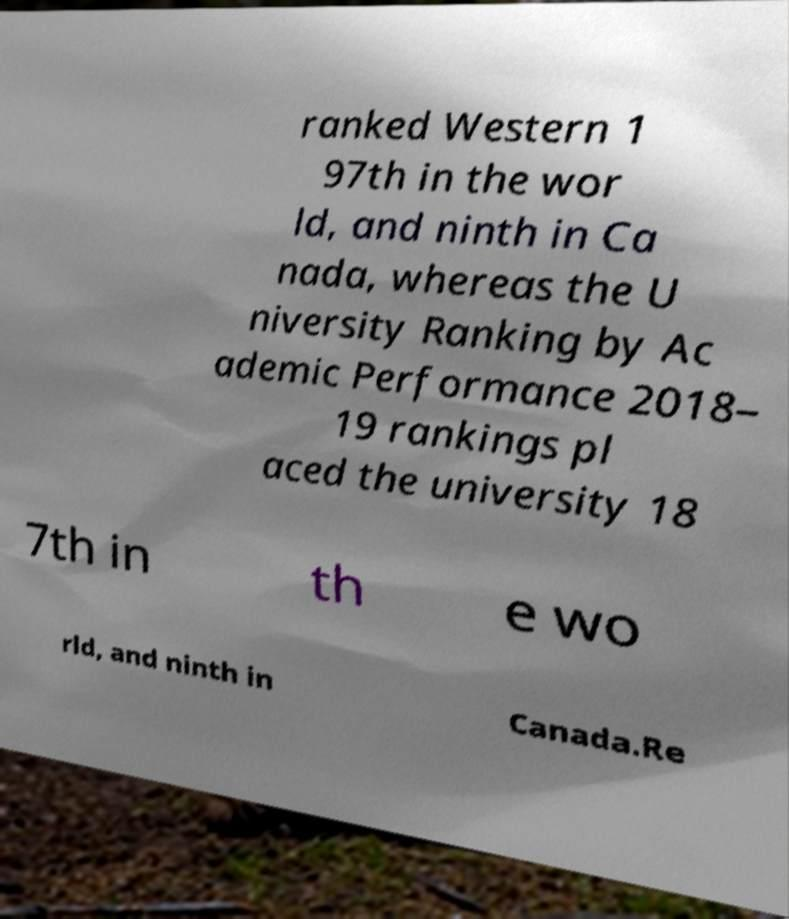Please identify and transcribe the text found in this image. ranked Western 1 97th in the wor ld, and ninth in Ca nada, whereas the U niversity Ranking by Ac ademic Performance 2018– 19 rankings pl aced the university 18 7th in th e wo rld, and ninth in Canada.Re 